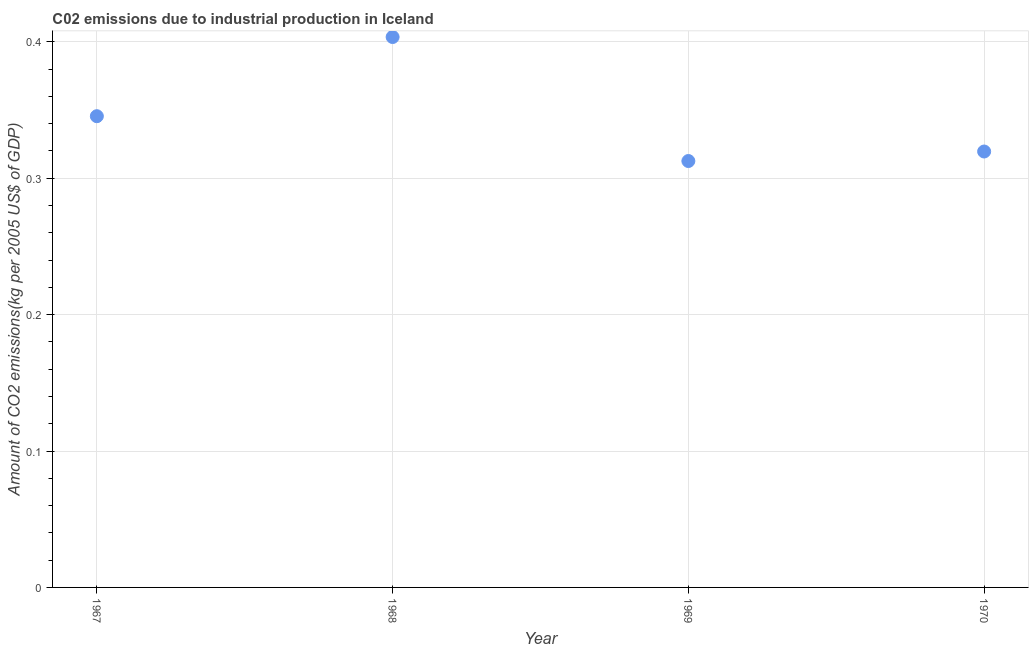What is the amount of co2 emissions in 1970?
Your response must be concise. 0.32. Across all years, what is the maximum amount of co2 emissions?
Your answer should be very brief. 0.4. Across all years, what is the minimum amount of co2 emissions?
Give a very brief answer. 0.31. In which year was the amount of co2 emissions maximum?
Make the answer very short. 1968. In which year was the amount of co2 emissions minimum?
Give a very brief answer. 1969. What is the sum of the amount of co2 emissions?
Make the answer very short. 1.38. What is the difference between the amount of co2 emissions in 1967 and 1969?
Your answer should be very brief. 0.03. What is the average amount of co2 emissions per year?
Your response must be concise. 0.35. What is the median amount of co2 emissions?
Provide a succinct answer. 0.33. What is the ratio of the amount of co2 emissions in 1969 to that in 1970?
Keep it short and to the point. 0.98. Is the amount of co2 emissions in 1967 less than that in 1968?
Provide a short and direct response. Yes. Is the difference between the amount of co2 emissions in 1968 and 1969 greater than the difference between any two years?
Make the answer very short. Yes. What is the difference between the highest and the second highest amount of co2 emissions?
Offer a terse response. 0.06. Is the sum of the amount of co2 emissions in 1967 and 1969 greater than the maximum amount of co2 emissions across all years?
Keep it short and to the point. Yes. What is the difference between the highest and the lowest amount of co2 emissions?
Ensure brevity in your answer.  0.09. How many years are there in the graph?
Provide a succinct answer. 4. What is the difference between two consecutive major ticks on the Y-axis?
Keep it short and to the point. 0.1. Does the graph contain any zero values?
Your answer should be compact. No. Does the graph contain grids?
Your response must be concise. Yes. What is the title of the graph?
Your answer should be very brief. C02 emissions due to industrial production in Iceland. What is the label or title of the Y-axis?
Your answer should be very brief. Amount of CO2 emissions(kg per 2005 US$ of GDP). What is the Amount of CO2 emissions(kg per 2005 US$ of GDP) in 1967?
Provide a succinct answer. 0.35. What is the Amount of CO2 emissions(kg per 2005 US$ of GDP) in 1968?
Offer a terse response. 0.4. What is the Amount of CO2 emissions(kg per 2005 US$ of GDP) in 1969?
Offer a terse response. 0.31. What is the Amount of CO2 emissions(kg per 2005 US$ of GDP) in 1970?
Keep it short and to the point. 0.32. What is the difference between the Amount of CO2 emissions(kg per 2005 US$ of GDP) in 1967 and 1968?
Keep it short and to the point. -0.06. What is the difference between the Amount of CO2 emissions(kg per 2005 US$ of GDP) in 1967 and 1969?
Ensure brevity in your answer.  0.03. What is the difference between the Amount of CO2 emissions(kg per 2005 US$ of GDP) in 1967 and 1970?
Offer a very short reply. 0.03. What is the difference between the Amount of CO2 emissions(kg per 2005 US$ of GDP) in 1968 and 1969?
Your response must be concise. 0.09. What is the difference between the Amount of CO2 emissions(kg per 2005 US$ of GDP) in 1968 and 1970?
Offer a terse response. 0.08. What is the difference between the Amount of CO2 emissions(kg per 2005 US$ of GDP) in 1969 and 1970?
Make the answer very short. -0.01. What is the ratio of the Amount of CO2 emissions(kg per 2005 US$ of GDP) in 1967 to that in 1968?
Provide a short and direct response. 0.86. What is the ratio of the Amount of CO2 emissions(kg per 2005 US$ of GDP) in 1967 to that in 1969?
Keep it short and to the point. 1.1. What is the ratio of the Amount of CO2 emissions(kg per 2005 US$ of GDP) in 1967 to that in 1970?
Your answer should be very brief. 1.08. What is the ratio of the Amount of CO2 emissions(kg per 2005 US$ of GDP) in 1968 to that in 1969?
Make the answer very short. 1.29. What is the ratio of the Amount of CO2 emissions(kg per 2005 US$ of GDP) in 1968 to that in 1970?
Provide a short and direct response. 1.26. 